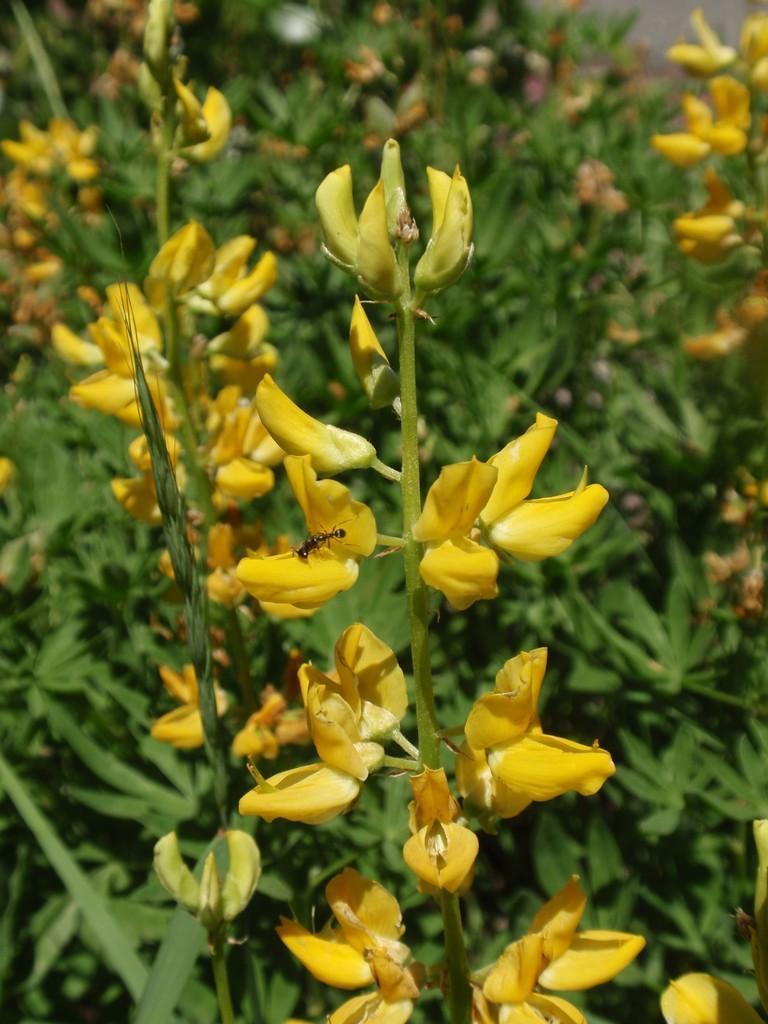How would you summarize this image in a sentence or two? In this image I can see there are yellow color flowers and buds to these plants. In the middle it looks like an ant. 